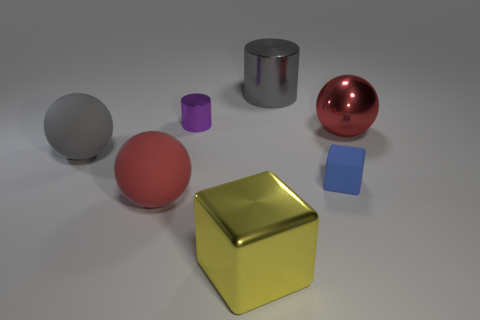Subtract all cyan cylinders. How many red spheres are left? 2 Add 1 big gray matte objects. How many objects exist? 8 Subtract all big red matte spheres. How many spheres are left? 2 Subtract 1 spheres. How many spheres are left? 2 Subtract all cylinders. How many objects are left? 5 Subtract all yellow metal objects. Subtract all small matte objects. How many objects are left? 5 Add 2 tiny cubes. How many tiny cubes are left? 3 Add 4 big red metallic balls. How many big red metallic balls exist? 5 Subtract 0 blue cylinders. How many objects are left? 7 Subtract all green spheres. Subtract all yellow blocks. How many spheres are left? 3 